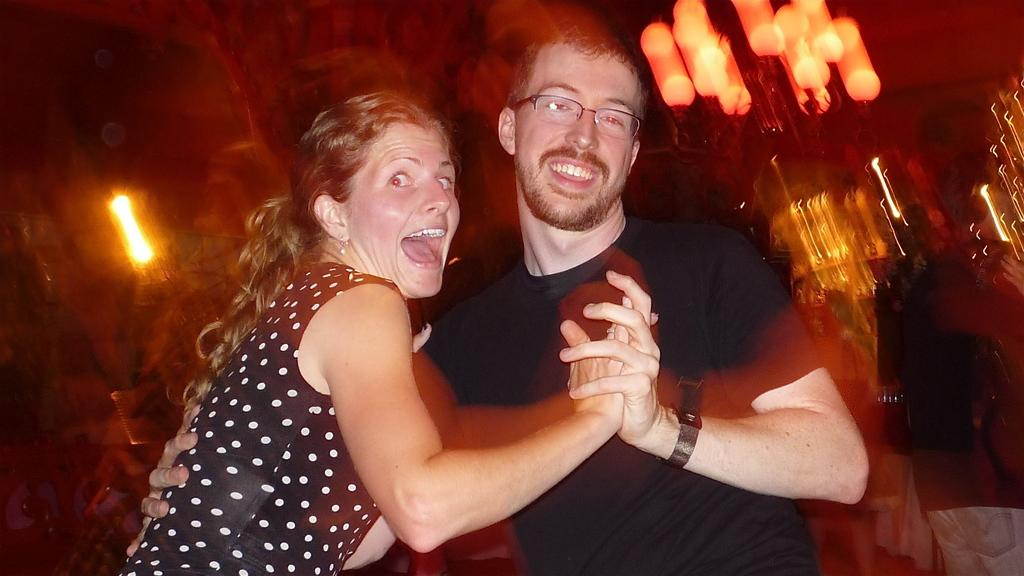How many people are in the image? There are two people in the image, a man and a woman. What is the facial expression of the man in the image? The man is smiling in the image. What accessory is the man wearing? The man is wearing spectacles in the image. Can you describe the background of the image? The background of the image is blurred. What can be seen in the image that provides illumination? There are lights visible in the image. What type of stem is the man holding in the image? There is no stem present in the image; the man is not holding anything. 